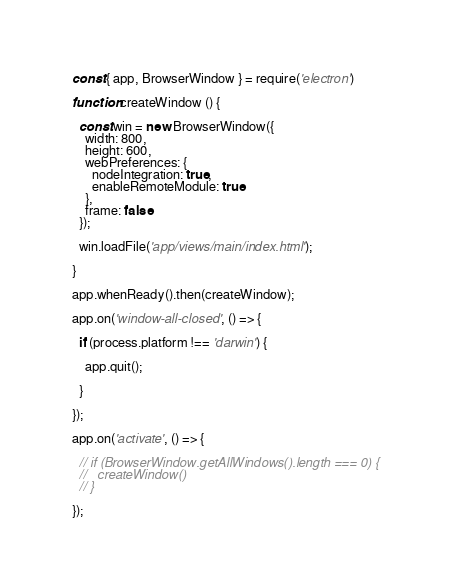Convert code to text. <code><loc_0><loc_0><loc_500><loc_500><_JavaScript_>const { app, BrowserWindow } = require('electron')

function createWindow () {

  const win = new BrowserWindow({
    width: 800,
    height: 600,
    webPreferences: {
      nodeIntegration: true,
      enableRemoteModule: true
    },
    frame: false
  });

  win.loadFile('app/views/main/index.html');

}

app.whenReady().then(createWindow);

app.on('window-all-closed', () => {

  if (process.platform !== 'darwin') {

    app.quit();

  }

});

app.on('activate', () => {

  // if (BrowserWindow.getAllWindows().length === 0) {
  //   createWindow()
  // }

});
</code> 